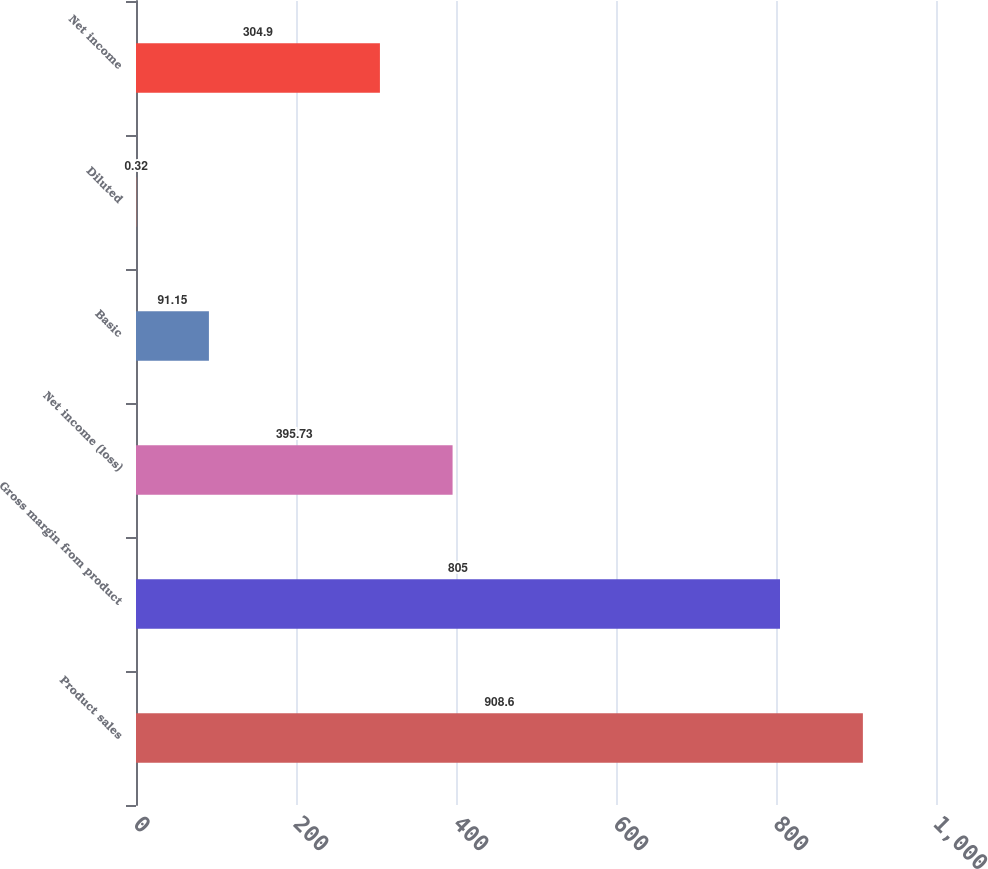<chart> <loc_0><loc_0><loc_500><loc_500><bar_chart><fcel>Product sales<fcel>Gross margin from product<fcel>Net income (loss)<fcel>Basic<fcel>Diluted<fcel>Net income<nl><fcel>908.6<fcel>805<fcel>395.73<fcel>91.15<fcel>0.32<fcel>304.9<nl></chart> 